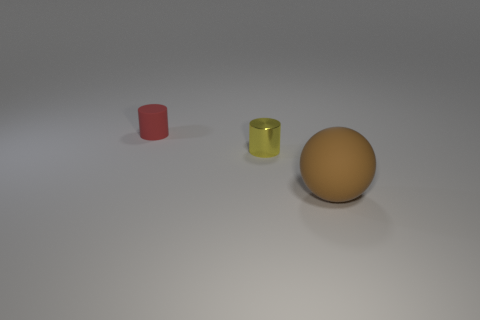Add 2 yellow metal cylinders. How many objects exist? 5 Subtract all cylinders. How many objects are left? 1 Subtract all large brown rubber objects. Subtract all large brown objects. How many objects are left? 1 Add 1 tiny objects. How many tiny objects are left? 3 Add 2 green rubber balls. How many green rubber balls exist? 2 Subtract 0 green cylinders. How many objects are left? 3 